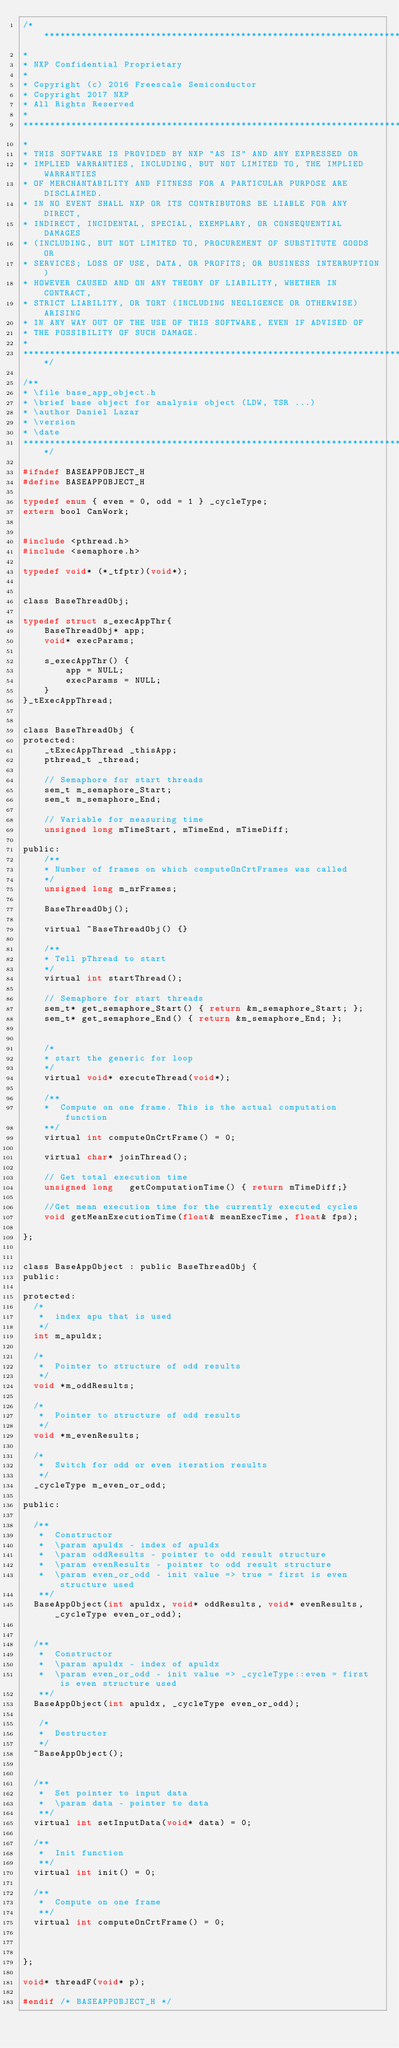Convert code to text. <code><loc_0><loc_0><loc_500><loc_500><_C_>/*****************************************************************************
* 
* NXP Confidential Proprietary
*
* Copyright (c) 2016 Freescale Semiconductor
* Copyright 2017 NXP 
* All Rights Reserved
*
******************************************************************************
*
* THIS SOFTWARE IS PROVIDED BY NXP "AS IS" AND ANY EXPRESSED OR
* IMPLIED WARRANTIES, INCLUDING, BUT NOT LIMITED TO, THE IMPLIED WARRANTIES
* OF MERCHANTABILITY AND FITNESS FOR A PARTICULAR PURPOSE ARE DISCLAIMED.
* IN NO EVENT SHALL NXP OR ITS CONTRIBUTORS BE LIABLE FOR ANY DIRECT,
* INDIRECT, INCIDENTAL, SPECIAL, EXEMPLARY, OR CONSEQUENTIAL DAMAGES
* (INCLUDING, BUT NOT LIMITED TO, PROCUREMENT OF SUBSTITUTE GOODS OR
* SERVICES; LOSS OF USE, DATA, OR PROFITS; OR BUSINESS INTERRUPTION)
* HOWEVER CAUSED AND ON ANY THEORY OF LIABILITY, WHETHER IN CONTRACT,
* STRICT LIABILITY, OR TORT (INCLUDING NEGLIGENCE OR OTHERWISE) ARISING
* IN ANY WAY OUT OF THE USE OF THIS SOFTWARE, EVEN IF ADVISED OF
* THE POSSIBILITY OF SUCH DAMAGE.
*
****************************************************************************/

/**
* \file base_app_object.h
* \brief base object for analysis object (LDW, TSR ...)
* \author Daniel Lazar
* \version
* \date
****************************************************************************/

#ifndef BASEAPPOBJECT_H
#define BASEAPPOBJECT_H

typedef enum { even = 0, odd = 1 } _cycleType;
extern bool CanWork;


#include <pthread.h>
#include <semaphore.h>

typedef void* (*_tfptr)(void*);


class BaseThreadObj;

typedef struct s_execAppThr{
	BaseThreadObj* app;
    void* execParams;

	s_execAppThr() {
		app = NULL;
		execParams = NULL;
	}
}_tExecAppThread;


class BaseThreadObj {
protected:
	_tExecAppThread _thisApp;
	pthread_t _thread;	

	// Semaphore for start threads
	sem_t m_semaphore_Start;
	sem_t m_semaphore_End;

	// Variable for measuring time
	unsigned long mTimeStart, mTimeEnd, mTimeDiff;

public:	
	/**
	* Number of frames on which computeOnCrtFrames was called
	*/
	unsigned long m_nrFrames;
	
	BaseThreadObj();

	virtual ~BaseThreadObj() {}

	/**
	* Tell pThread to start
	*/
	virtual int startThread();

	// Semaphore for start threads
	sem_t* get_semaphore_Start() { return &m_semaphore_Start; };
	sem_t* get_semaphore_End() { return &m_semaphore_End; };


	/*
	* start the generic for loop
	*/
	virtual void* executeThread(void*); 

	/**
	*  Compute on one frame. This is the actual computation function
	**/
	virtual int computeOnCrtFrame() = 0;

	virtual char* joinThread();
	
	// Get total execution time
	unsigned long 	getComputationTime() { return mTimeDiff;}

	//Get mean execution time for the currently executed cycles
	void getMeanExecutionTime(float& meanExecTime, float& fps);

};


class BaseAppObject : public BaseThreadObj {
public:

protected:
  /*
   *  index apu that is used
   */
  int m_apuldx;
 
  /*
   *  Pointer to structure of odd results
   */
  void *m_oddResults;
  
  /*
   *  Pointer to structure of odd results
   */
  void *m_evenResults;
  
  /*
   *  Switch for odd or even iteration results
   */
  _cycleType m_even_or_odd;
  
public:
  
  /**
   *  Constructor 
   *  \param apuldx - index of apuldx
   *  \param oddResults - pointer to odd result structure
   *  \param evenResults - pointer to odd result structure
   *  \param even_or_odd - init value => true = first is even structure used
   **/
  BaseAppObject(int apuldx, void* oddResults, void* evenResults, _cycleType even_or_odd);
  

  /**
   *  Constructor 
   *  \param apuldx - index of apuldx
   *  \param even_or_odd - init value => _cycleType::even = first is even structure used
   **/
  BaseAppObject(int apuldx, _cycleType even_or_odd);

   /*
   *  Destructor
   */
  ~BaseAppObject();
  
  
  /**
   *  Set pointer to input data
   *  \param data - pointer to data
   **/
  virtual int setInputData(void* data) = 0;
   
  /**
   *  Init function
   **/
  virtual int init() = 0;
  
  /**
   *  Compute on one frame 
   **/
  virtual int computeOnCrtFrame() = 0;
  


};

void* threadF(void* p);

#endif /* BASEAPPOBJECT_H */
</code> 